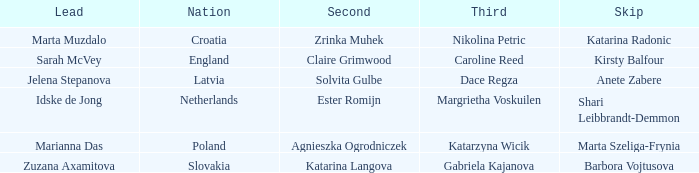Who is the Second with Nikolina Petric as Third? Zrinka Muhek. 